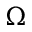Convert formula to latex. <formula><loc_0><loc_0><loc_500><loc_500>\Omega</formula> 